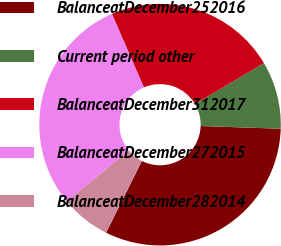Convert chart to OTSL. <chart><loc_0><loc_0><loc_500><loc_500><pie_chart><fcel>BalanceatDecember252016<fcel>Current period other<fcel>BalanceatDecember312017<fcel>BalanceatDecember272015<fcel>BalanceatDecember282014<nl><fcel>31.84%<fcel>9.05%<fcel>23.01%<fcel>29.44%<fcel>6.66%<nl></chart> 